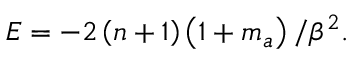Convert formula to latex. <formula><loc_0><loc_0><loc_500><loc_500>E = - 2 \left ( n + 1 \right ) \left ( 1 + m _ { a } \right ) / \beta ^ { 2 } .</formula> 